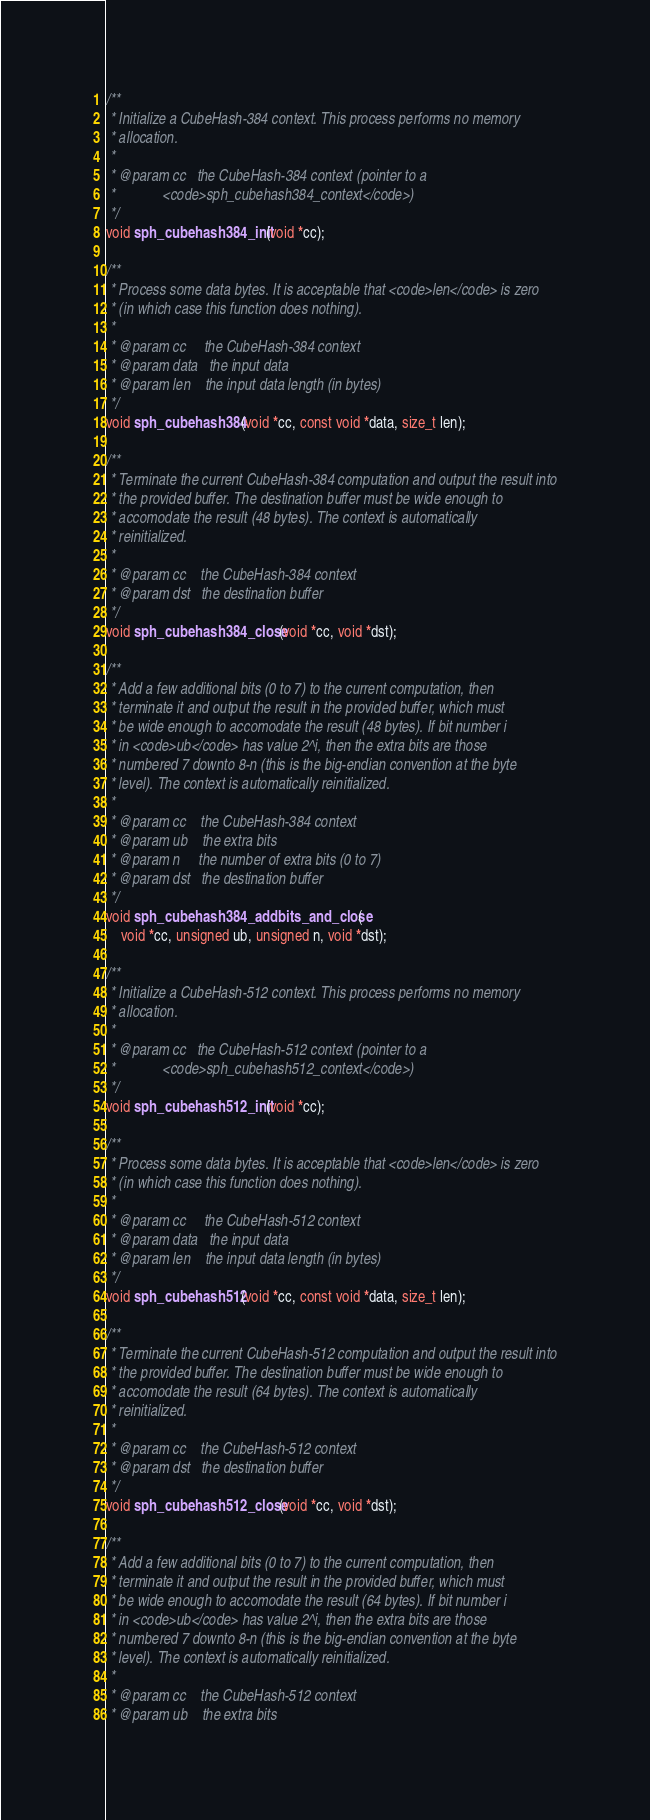Convert code to text. <code><loc_0><loc_0><loc_500><loc_500><_C_>/**
 * Initialize a CubeHash-384 context. This process performs no memory
 * allocation.
 *
 * @param cc   the CubeHash-384 context (pointer to a
 *             <code>sph_cubehash384_context</code>)
 */
void sph_cubehash384_init(void *cc);

/**
 * Process some data bytes. It is acceptable that <code>len</code> is zero
 * (in which case this function does nothing).
 *
 * @param cc     the CubeHash-384 context
 * @param data   the input data
 * @param len    the input data length (in bytes)
 */
void sph_cubehash384(void *cc, const void *data, size_t len);

/**
 * Terminate the current CubeHash-384 computation and output the result into
 * the provided buffer. The destination buffer must be wide enough to
 * accomodate the result (48 bytes). The context is automatically
 * reinitialized.
 *
 * @param cc    the CubeHash-384 context
 * @param dst   the destination buffer
 */
void sph_cubehash384_close(void *cc, void *dst);

/**
 * Add a few additional bits (0 to 7) to the current computation, then
 * terminate it and output the result in the provided buffer, which must
 * be wide enough to accomodate the result (48 bytes). If bit number i
 * in <code>ub</code> has value 2^i, then the extra bits are those
 * numbered 7 downto 8-n (this is the big-endian convention at the byte
 * level). The context is automatically reinitialized.
 *
 * @param cc    the CubeHash-384 context
 * @param ub    the extra bits
 * @param n     the number of extra bits (0 to 7)
 * @param dst   the destination buffer
 */
void sph_cubehash384_addbits_and_close(
	void *cc, unsigned ub, unsigned n, void *dst);

/**
 * Initialize a CubeHash-512 context. This process performs no memory
 * allocation.
 *
 * @param cc   the CubeHash-512 context (pointer to a
 *             <code>sph_cubehash512_context</code>)
 */
void sph_cubehash512_init(void *cc);

/**
 * Process some data bytes. It is acceptable that <code>len</code> is zero
 * (in which case this function does nothing).
 *
 * @param cc     the CubeHash-512 context
 * @param data   the input data
 * @param len    the input data length (in bytes)
 */
void sph_cubehash512(void *cc, const void *data, size_t len);

/**
 * Terminate the current CubeHash-512 computation and output the result into
 * the provided buffer. The destination buffer must be wide enough to
 * accomodate the result (64 bytes). The context is automatically
 * reinitialized.
 *
 * @param cc    the CubeHash-512 context
 * @param dst   the destination buffer
 */
void sph_cubehash512_close(void *cc, void *dst);

/**
 * Add a few additional bits (0 to 7) to the current computation, then
 * terminate it and output the result in the provided buffer, which must
 * be wide enough to accomodate the result (64 bytes). If bit number i
 * in <code>ub</code> has value 2^i, then the extra bits are those
 * numbered 7 downto 8-n (this is the big-endian convention at the byte
 * level). The context is automatically reinitialized.
 *
 * @param cc    the CubeHash-512 context
 * @param ub    the extra bits</code> 